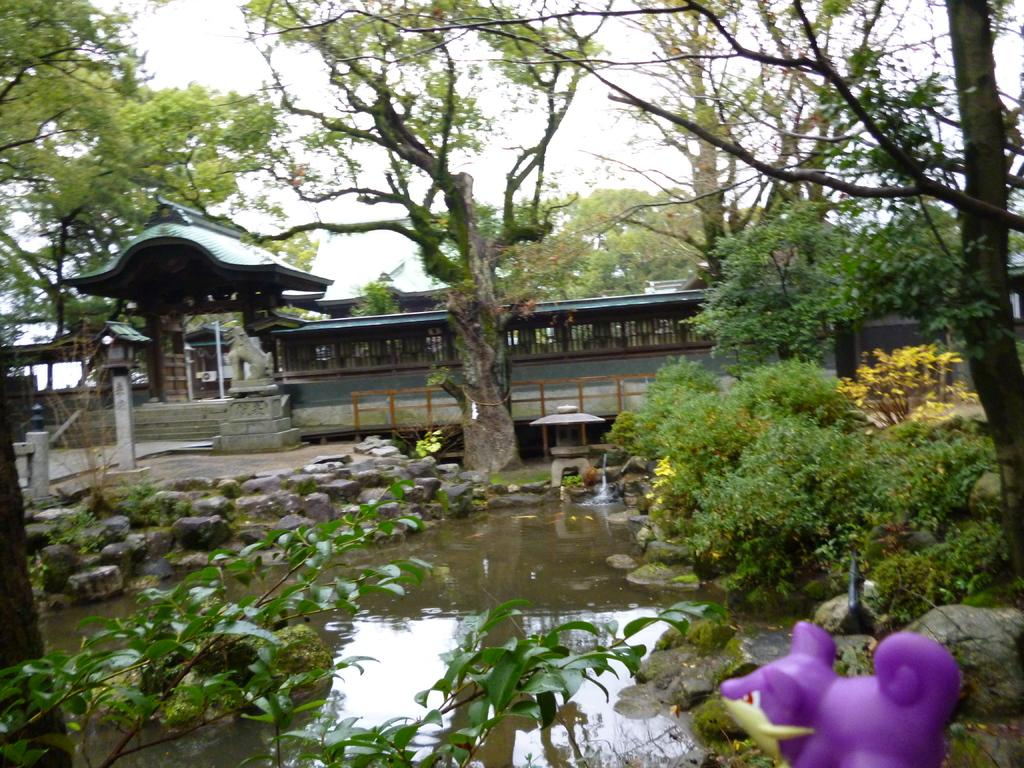What color is the toy that can be seen in the image? The toy in the image is purple. What natural element is visible in the image? Water is visible in the image. What type of vegetation is present in the image? Plants and trees are present in the image. What type of material is used for the fence in the image? The fence in the image is made of stones. What architectural feature can be seen in the image? There is an arch in the image. What type of entrance is visible in the image? There is a gate in the image. What type of structure is present in the image? There is a wall in the image. What can be seen in the background of the image? The sky is visible in the background of the image. What type of note is being played by the tree in the image? There is no note being played by the tree in the image, as trees do not have the ability to play music. What type of ring can be seen on the stone fence in the image? There is no ring present on the stone fence in the image. 